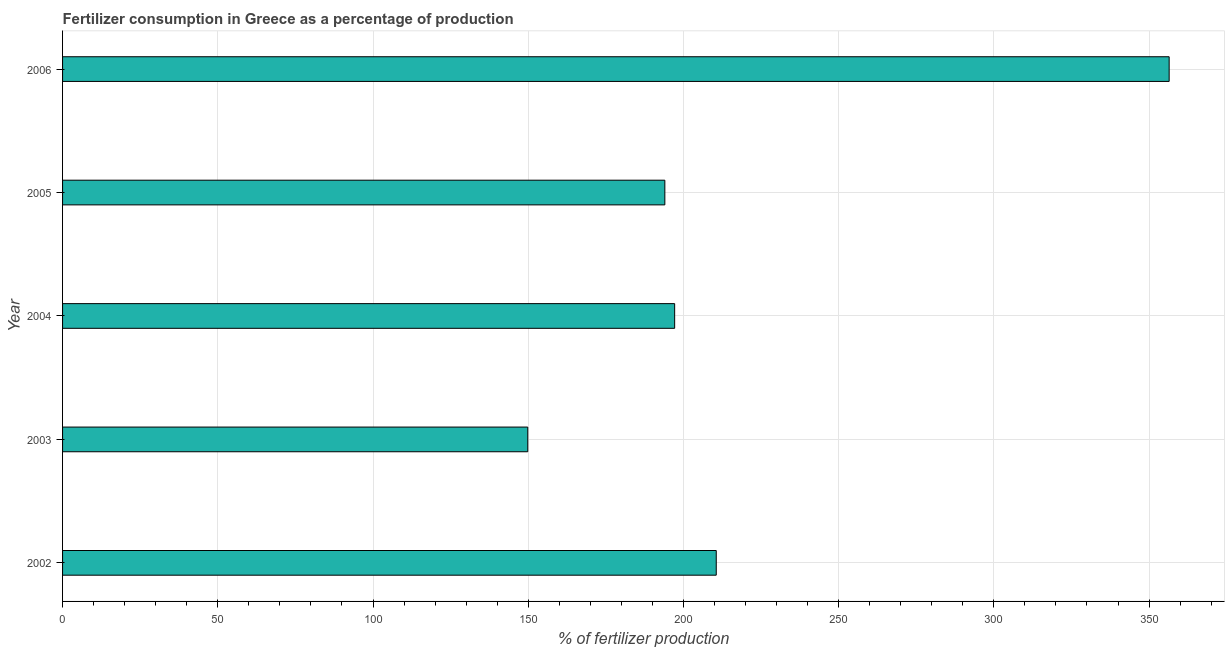Does the graph contain any zero values?
Ensure brevity in your answer.  No. What is the title of the graph?
Your answer should be very brief. Fertilizer consumption in Greece as a percentage of production. What is the label or title of the X-axis?
Offer a terse response. % of fertilizer production. What is the amount of fertilizer consumption in 2002?
Provide a short and direct response. 210.57. Across all years, what is the maximum amount of fertilizer consumption?
Offer a very short reply. 356.47. Across all years, what is the minimum amount of fertilizer consumption?
Offer a terse response. 149.85. In which year was the amount of fertilizer consumption maximum?
Your answer should be compact. 2006. What is the sum of the amount of fertilizer consumption?
Your answer should be compact. 1108.09. What is the difference between the amount of fertilizer consumption in 2003 and 2004?
Offer a terse response. -47.32. What is the average amount of fertilizer consumption per year?
Give a very brief answer. 221.62. What is the median amount of fertilizer consumption?
Give a very brief answer. 197.18. In how many years, is the amount of fertilizer consumption greater than 20 %?
Keep it short and to the point. 5. What is the ratio of the amount of fertilizer consumption in 2002 to that in 2006?
Your answer should be compact. 0.59. What is the difference between the highest and the second highest amount of fertilizer consumption?
Your answer should be compact. 145.9. What is the difference between the highest and the lowest amount of fertilizer consumption?
Make the answer very short. 206.62. In how many years, is the amount of fertilizer consumption greater than the average amount of fertilizer consumption taken over all years?
Give a very brief answer. 1. How many bars are there?
Provide a succinct answer. 5. What is the % of fertilizer production of 2002?
Offer a very short reply. 210.57. What is the % of fertilizer production of 2003?
Your answer should be very brief. 149.85. What is the % of fertilizer production of 2004?
Your answer should be very brief. 197.18. What is the % of fertilizer production in 2005?
Keep it short and to the point. 194.01. What is the % of fertilizer production in 2006?
Provide a short and direct response. 356.47. What is the difference between the % of fertilizer production in 2002 and 2003?
Your answer should be compact. 60.72. What is the difference between the % of fertilizer production in 2002 and 2004?
Offer a very short reply. 13.4. What is the difference between the % of fertilizer production in 2002 and 2005?
Your answer should be very brief. 16.56. What is the difference between the % of fertilizer production in 2002 and 2006?
Offer a terse response. -145.9. What is the difference between the % of fertilizer production in 2003 and 2004?
Keep it short and to the point. -47.32. What is the difference between the % of fertilizer production in 2003 and 2005?
Ensure brevity in your answer.  -44.16. What is the difference between the % of fertilizer production in 2003 and 2006?
Offer a very short reply. -206.62. What is the difference between the % of fertilizer production in 2004 and 2005?
Make the answer very short. 3.16. What is the difference between the % of fertilizer production in 2004 and 2006?
Keep it short and to the point. -159.29. What is the difference between the % of fertilizer production in 2005 and 2006?
Offer a terse response. -162.46. What is the ratio of the % of fertilizer production in 2002 to that in 2003?
Offer a very short reply. 1.41. What is the ratio of the % of fertilizer production in 2002 to that in 2004?
Give a very brief answer. 1.07. What is the ratio of the % of fertilizer production in 2002 to that in 2005?
Give a very brief answer. 1.08. What is the ratio of the % of fertilizer production in 2002 to that in 2006?
Offer a terse response. 0.59. What is the ratio of the % of fertilizer production in 2003 to that in 2004?
Offer a terse response. 0.76. What is the ratio of the % of fertilizer production in 2003 to that in 2005?
Your answer should be very brief. 0.77. What is the ratio of the % of fertilizer production in 2003 to that in 2006?
Your answer should be very brief. 0.42. What is the ratio of the % of fertilizer production in 2004 to that in 2006?
Make the answer very short. 0.55. What is the ratio of the % of fertilizer production in 2005 to that in 2006?
Offer a terse response. 0.54. 